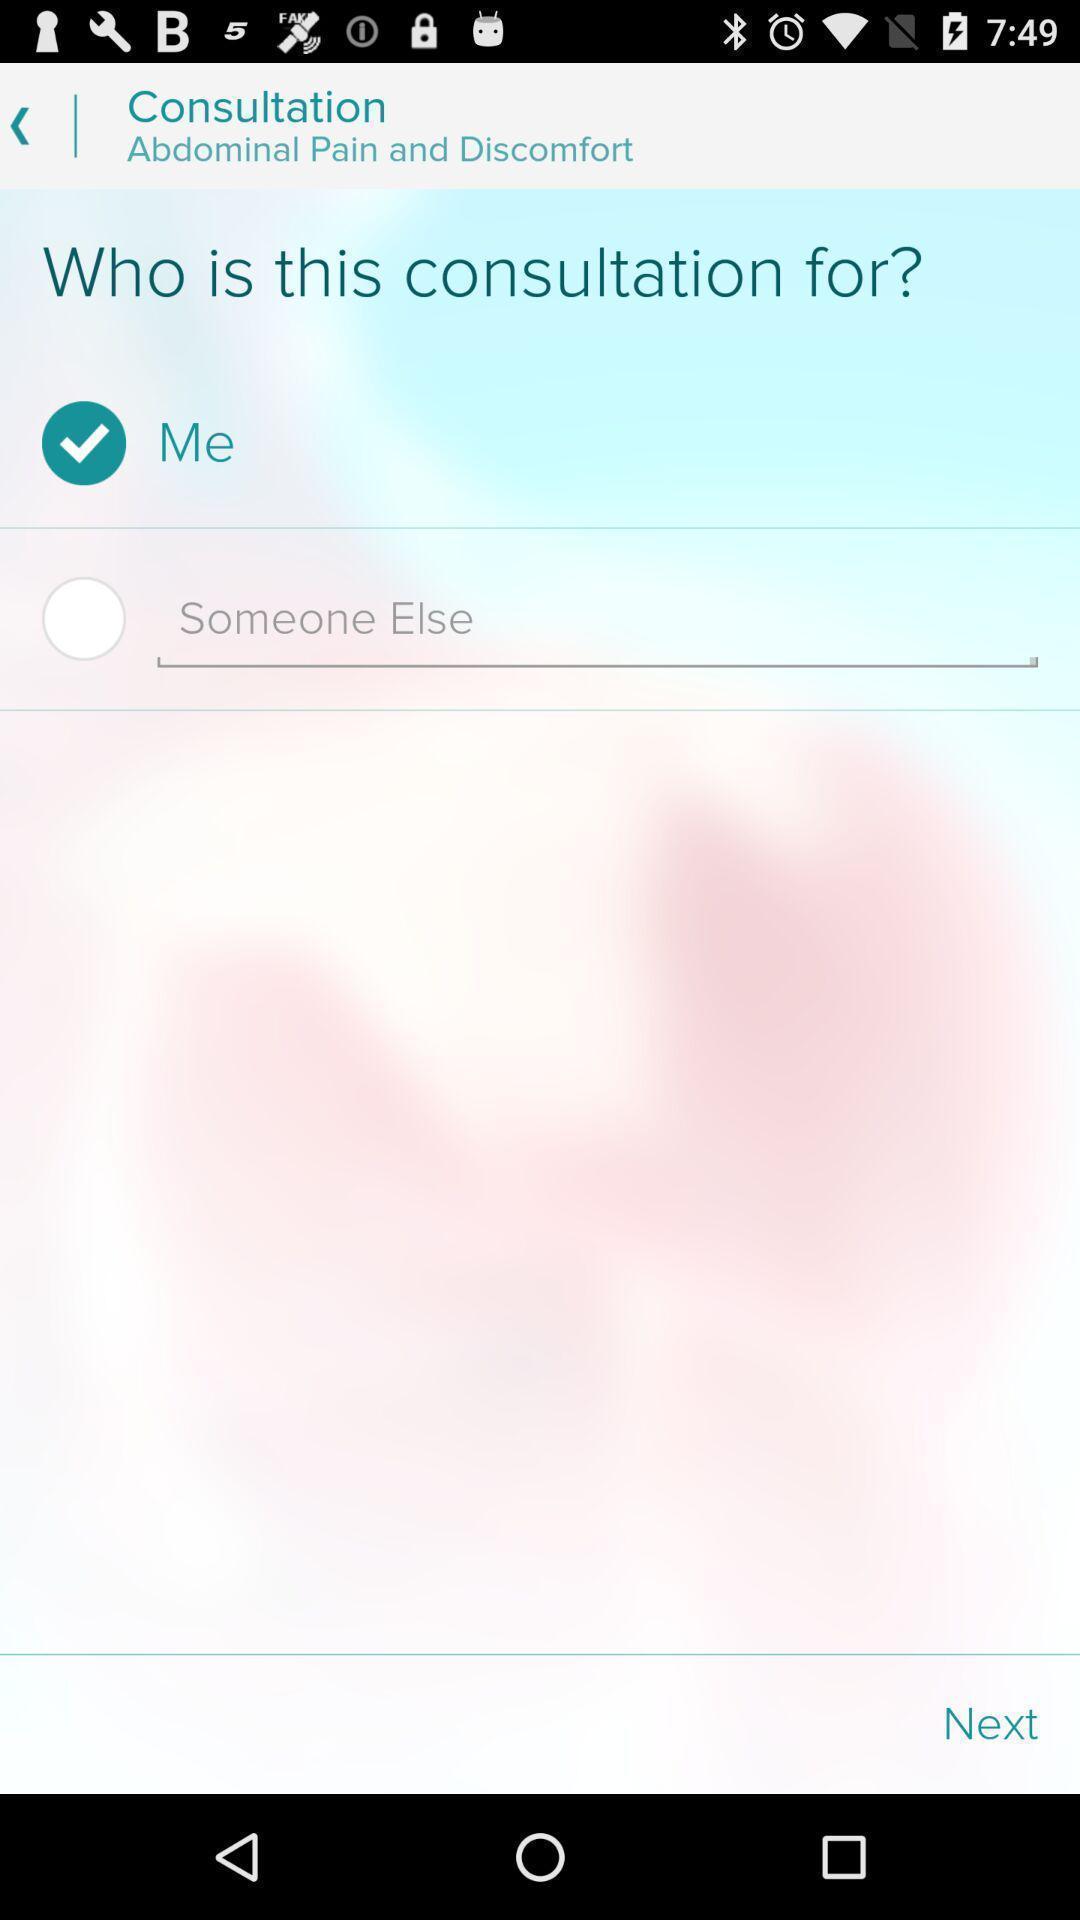Provide a detailed account of this screenshot. Page displaying query of consultation. 